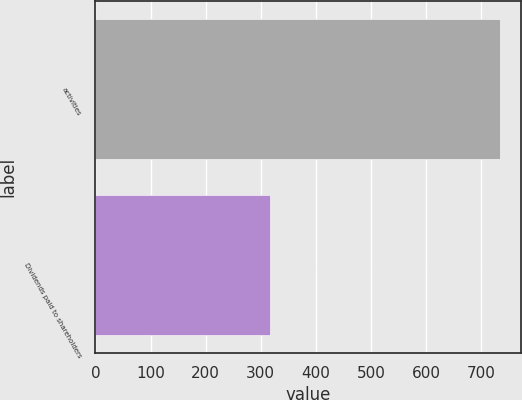<chart> <loc_0><loc_0><loc_500><loc_500><bar_chart><fcel>activities<fcel>Dividends paid to shareholders<nl><fcel>735<fcel>316<nl></chart> 